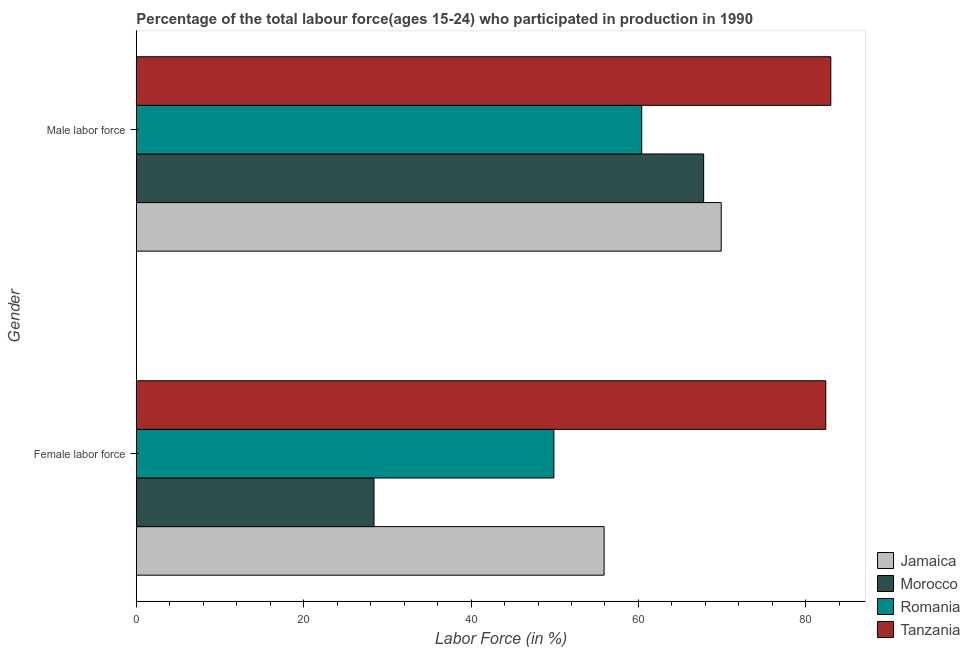How many different coloured bars are there?
Ensure brevity in your answer.  4. Are the number of bars on each tick of the Y-axis equal?
Provide a short and direct response. Yes. What is the label of the 2nd group of bars from the top?
Keep it short and to the point. Female labor force. What is the percentage of female labor force in Morocco?
Offer a terse response. 28.4. Across all countries, what is the maximum percentage of male labour force?
Your response must be concise. 83. Across all countries, what is the minimum percentage of male labour force?
Your answer should be very brief. 60.4. In which country was the percentage of male labour force maximum?
Provide a succinct answer. Tanzania. In which country was the percentage of female labor force minimum?
Your answer should be very brief. Morocco. What is the total percentage of male labour force in the graph?
Provide a succinct answer. 281.1. What is the difference between the percentage of male labour force in Tanzania and that in Jamaica?
Offer a very short reply. 13.1. What is the difference between the percentage of male labour force in Tanzania and the percentage of female labor force in Romania?
Keep it short and to the point. 33.1. What is the average percentage of female labor force per country?
Give a very brief answer. 54.15. What is the ratio of the percentage of male labour force in Tanzania to that in Romania?
Provide a succinct answer. 1.37. Is the percentage of male labour force in Jamaica less than that in Tanzania?
Your response must be concise. Yes. In how many countries, is the percentage of female labor force greater than the average percentage of female labor force taken over all countries?
Give a very brief answer. 2. What does the 4th bar from the top in Female labor force represents?
Provide a succinct answer. Jamaica. What does the 1st bar from the bottom in Female labor force represents?
Your answer should be compact. Jamaica. Are all the bars in the graph horizontal?
Make the answer very short. Yes. What is the difference between two consecutive major ticks on the X-axis?
Keep it short and to the point. 20. Are the values on the major ticks of X-axis written in scientific E-notation?
Your response must be concise. No. Where does the legend appear in the graph?
Offer a very short reply. Bottom right. How are the legend labels stacked?
Ensure brevity in your answer.  Vertical. What is the title of the graph?
Give a very brief answer. Percentage of the total labour force(ages 15-24) who participated in production in 1990. What is the label or title of the X-axis?
Your response must be concise. Labor Force (in %). What is the Labor Force (in %) of Jamaica in Female labor force?
Keep it short and to the point. 55.9. What is the Labor Force (in %) of Morocco in Female labor force?
Give a very brief answer. 28.4. What is the Labor Force (in %) in Romania in Female labor force?
Keep it short and to the point. 49.9. What is the Labor Force (in %) of Tanzania in Female labor force?
Offer a terse response. 82.4. What is the Labor Force (in %) in Jamaica in Male labor force?
Ensure brevity in your answer.  69.9. What is the Labor Force (in %) of Morocco in Male labor force?
Make the answer very short. 67.8. What is the Labor Force (in %) of Romania in Male labor force?
Your response must be concise. 60.4. What is the Labor Force (in %) of Tanzania in Male labor force?
Your response must be concise. 83. Across all Gender, what is the maximum Labor Force (in %) in Jamaica?
Keep it short and to the point. 69.9. Across all Gender, what is the maximum Labor Force (in %) of Morocco?
Your answer should be very brief. 67.8. Across all Gender, what is the maximum Labor Force (in %) in Romania?
Offer a very short reply. 60.4. Across all Gender, what is the minimum Labor Force (in %) of Jamaica?
Your answer should be very brief. 55.9. Across all Gender, what is the minimum Labor Force (in %) in Morocco?
Give a very brief answer. 28.4. Across all Gender, what is the minimum Labor Force (in %) of Romania?
Keep it short and to the point. 49.9. Across all Gender, what is the minimum Labor Force (in %) of Tanzania?
Make the answer very short. 82.4. What is the total Labor Force (in %) in Jamaica in the graph?
Your response must be concise. 125.8. What is the total Labor Force (in %) of Morocco in the graph?
Your answer should be very brief. 96.2. What is the total Labor Force (in %) of Romania in the graph?
Your answer should be very brief. 110.3. What is the total Labor Force (in %) in Tanzania in the graph?
Provide a succinct answer. 165.4. What is the difference between the Labor Force (in %) of Jamaica in Female labor force and that in Male labor force?
Provide a succinct answer. -14. What is the difference between the Labor Force (in %) in Morocco in Female labor force and that in Male labor force?
Your answer should be very brief. -39.4. What is the difference between the Labor Force (in %) in Tanzania in Female labor force and that in Male labor force?
Ensure brevity in your answer.  -0.6. What is the difference between the Labor Force (in %) in Jamaica in Female labor force and the Labor Force (in %) in Morocco in Male labor force?
Your response must be concise. -11.9. What is the difference between the Labor Force (in %) of Jamaica in Female labor force and the Labor Force (in %) of Romania in Male labor force?
Your response must be concise. -4.5. What is the difference between the Labor Force (in %) in Jamaica in Female labor force and the Labor Force (in %) in Tanzania in Male labor force?
Keep it short and to the point. -27.1. What is the difference between the Labor Force (in %) in Morocco in Female labor force and the Labor Force (in %) in Romania in Male labor force?
Give a very brief answer. -32. What is the difference between the Labor Force (in %) of Morocco in Female labor force and the Labor Force (in %) of Tanzania in Male labor force?
Your answer should be very brief. -54.6. What is the difference between the Labor Force (in %) in Romania in Female labor force and the Labor Force (in %) in Tanzania in Male labor force?
Provide a succinct answer. -33.1. What is the average Labor Force (in %) in Jamaica per Gender?
Keep it short and to the point. 62.9. What is the average Labor Force (in %) of Morocco per Gender?
Your answer should be compact. 48.1. What is the average Labor Force (in %) in Romania per Gender?
Keep it short and to the point. 55.15. What is the average Labor Force (in %) of Tanzania per Gender?
Offer a very short reply. 82.7. What is the difference between the Labor Force (in %) in Jamaica and Labor Force (in %) in Morocco in Female labor force?
Offer a terse response. 27.5. What is the difference between the Labor Force (in %) in Jamaica and Labor Force (in %) in Tanzania in Female labor force?
Your answer should be compact. -26.5. What is the difference between the Labor Force (in %) in Morocco and Labor Force (in %) in Romania in Female labor force?
Offer a terse response. -21.5. What is the difference between the Labor Force (in %) in Morocco and Labor Force (in %) in Tanzania in Female labor force?
Your answer should be compact. -54. What is the difference between the Labor Force (in %) in Romania and Labor Force (in %) in Tanzania in Female labor force?
Your answer should be compact. -32.5. What is the difference between the Labor Force (in %) of Jamaica and Labor Force (in %) of Romania in Male labor force?
Offer a very short reply. 9.5. What is the difference between the Labor Force (in %) of Morocco and Labor Force (in %) of Tanzania in Male labor force?
Offer a very short reply. -15.2. What is the difference between the Labor Force (in %) of Romania and Labor Force (in %) of Tanzania in Male labor force?
Provide a succinct answer. -22.6. What is the ratio of the Labor Force (in %) in Jamaica in Female labor force to that in Male labor force?
Keep it short and to the point. 0.8. What is the ratio of the Labor Force (in %) of Morocco in Female labor force to that in Male labor force?
Make the answer very short. 0.42. What is the ratio of the Labor Force (in %) of Romania in Female labor force to that in Male labor force?
Make the answer very short. 0.83. What is the ratio of the Labor Force (in %) of Tanzania in Female labor force to that in Male labor force?
Ensure brevity in your answer.  0.99. What is the difference between the highest and the second highest Labor Force (in %) in Morocco?
Your answer should be very brief. 39.4. What is the difference between the highest and the second highest Labor Force (in %) in Tanzania?
Your answer should be compact. 0.6. What is the difference between the highest and the lowest Labor Force (in %) in Morocco?
Provide a succinct answer. 39.4. What is the difference between the highest and the lowest Labor Force (in %) of Romania?
Make the answer very short. 10.5. 